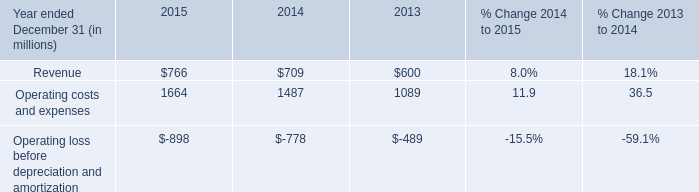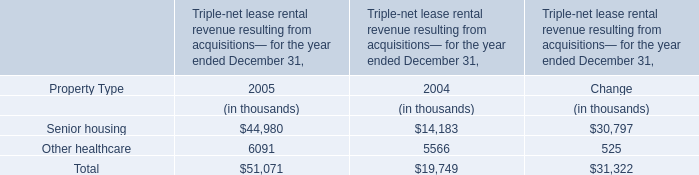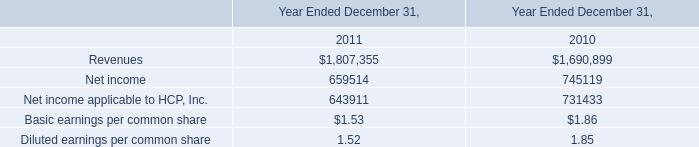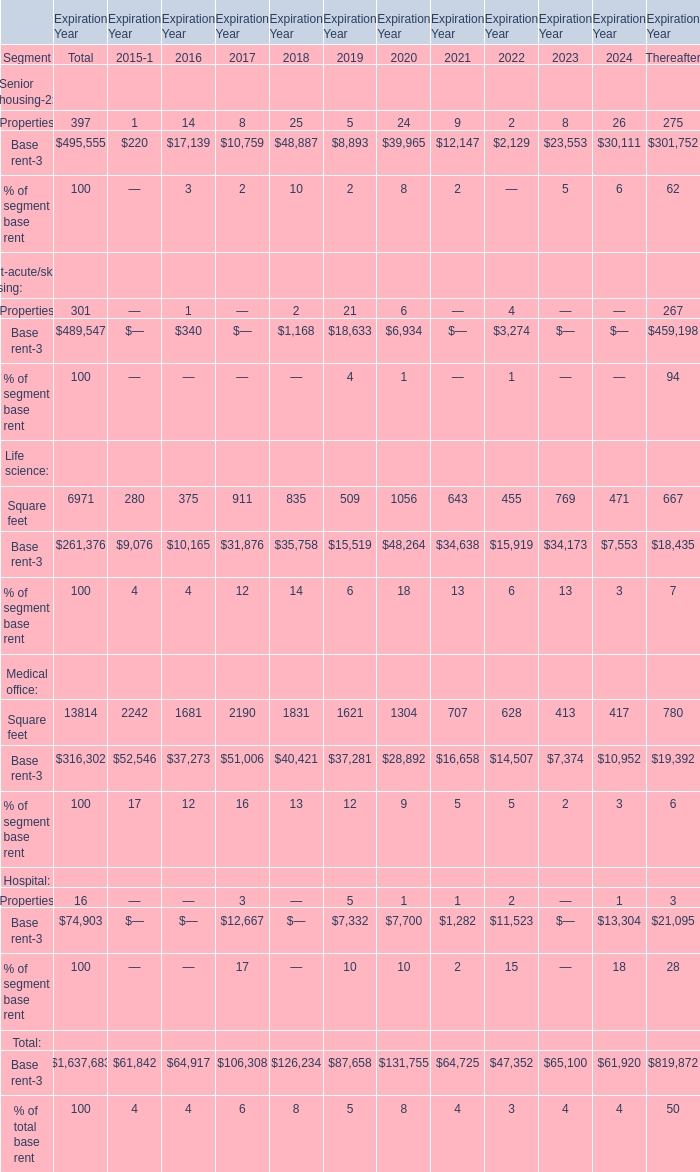What's the sum of all Properties that are positive in 2016 and 2017? 
Computations: (14 + 8)
Answer: 22.0. 